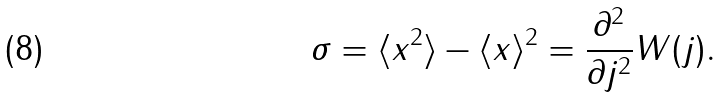<formula> <loc_0><loc_0><loc_500><loc_500>\sigma = \langle x ^ { 2 } \rangle - \langle x \rangle ^ { 2 } = \frac { \partial ^ { 2 } } { \partial j ^ { 2 } } W ( j ) .</formula> 